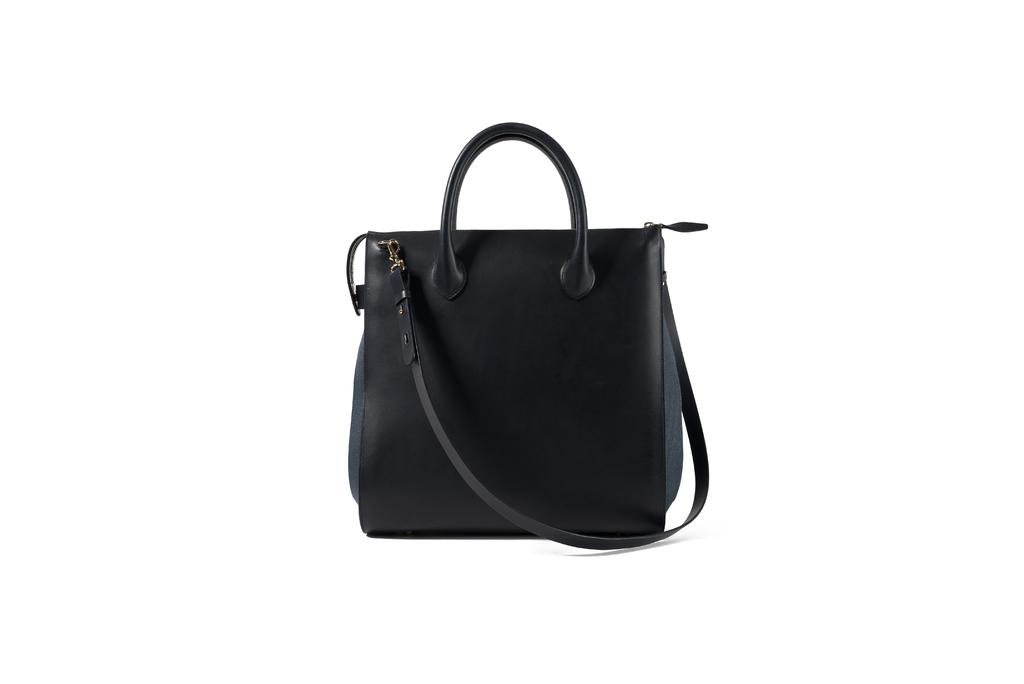What type of accessory is visible in the image? There is a black handbag in the image. What color is the background of the image? The background of the image is white. How many jelly containers are visible in the image? There are no jelly containers present in the image. Is there a fan visible in the image? There is no fan present in the image. 